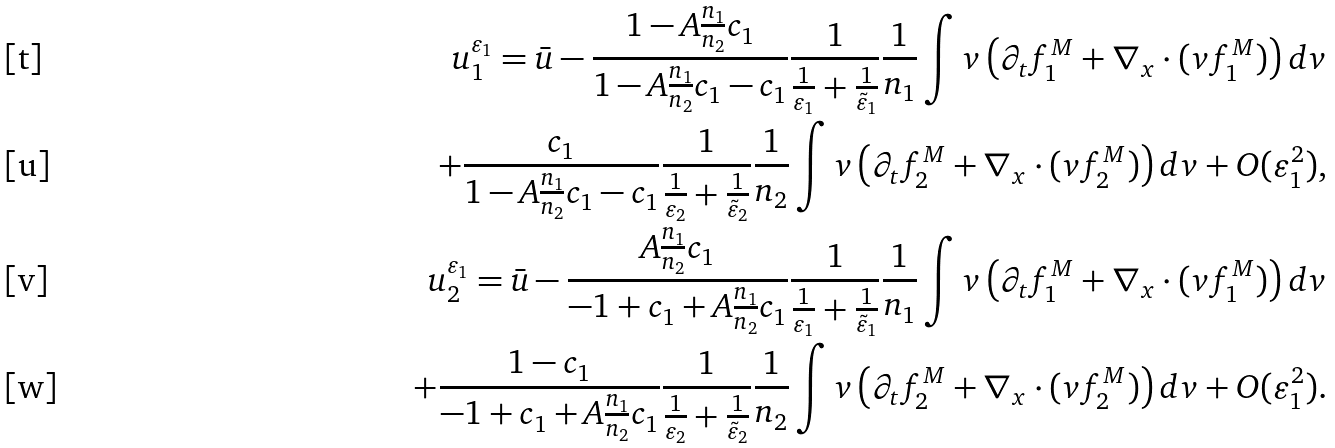Convert formula to latex. <formula><loc_0><loc_0><loc_500><loc_500>u _ { 1 } ^ { \varepsilon _ { 1 } } = \bar { u } - \frac { 1 - A \frac { n _ { 1 } } { n _ { 2 } } c _ { 1 } } { 1 - A \frac { n _ { 1 } } { n _ { 2 } } c _ { 1 } - c _ { 1 } } \frac { 1 } { \frac { 1 } { \varepsilon _ { 1 } } + \frac { 1 } { \tilde { \varepsilon } _ { 1 } } } \frac { 1 } { n _ { 1 } } \int v \left ( \partial _ { t } f _ { 1 } ^ { M } + \nabla _ { x } \cdot ( v f _ { 1 } ^ { M } ) \right ) d v \\ + \frac { c _ { 1 } } { 1 - A \frac { n _ { 1 } } { n _ { 2 } } c _ { 1 } - c _ { 1 } } \frac { 1 } { \frac { 1 } { \varepsilon _ { 2 } } + \frac { 1 } { \tilde { \varepsilon } _ { 2 } } } \frac { 1 } { n _ { 2 } } \int v \left ( \partial _ { t } f _ { 2 } ^ { M } + \nabla _ { x } \cdot ( v f _ { 2 } ^ { M } ) \right ) d v + O ( \varepsilon _ { 1 } ^ { 2 } ) , \\ u _ { 2 } ^ { \varepsilon _ { 1 } } = \bar { u } - \frac { A \frac { n _ { 1 } } { n _ { 2 } } c _ { 1 } } { - 1 + c _ { 1 } + A \frac { n _ { 1 } } { n _ { 2 } } c _ { 1 } } \frac { 1 } { \frac { 1 } { \varepsilon _ { 1 } } + \frac { 1 } { \tilde { \varepsilon } _ { 1 } } } \frac { 1 } { n _ { 1 } } \int v \left ( \partial _ { t } f _ { 1 } ^ { M } + \nabla _ { x } \cdot ( v f _ { 1 } ^ { M } ) \right ) d v \\ + \frac { 1 - c _ { 1 } } { - 1 + c _ { 1 } + A \frac { n _ { 1 } } { n _ { 2 } } c _ { 1 } } \frac { 1 } { \frac { 1 } { \varepsilon _ { 2 } } + \frac { 1 } { \tilde { \varepsilon } _ { 2 } } } \frac { 1 } { n _ { 2 } } \int v \left ( \partial _ { t } f _ { 2 } ^ { M } + \nabla _ { x } \cdot ( v f _ { 2 } ^ { M } ) \right ) d v + O ( \varepsilon _ { 1 } ^ { 2 } ) .</formula> 